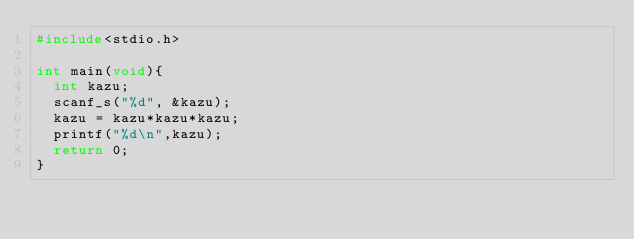Convert code to text. <code><loc_0><loc_0><loc_500><loc_500><_C_>#include<stdio.h>

int main(void){
	int kazu;
	scanf_s("%d", &kazu);
	kazu = kazu*kazu*kazu;
	printf("%d\n",kazu);
	return 0;
}</code> 